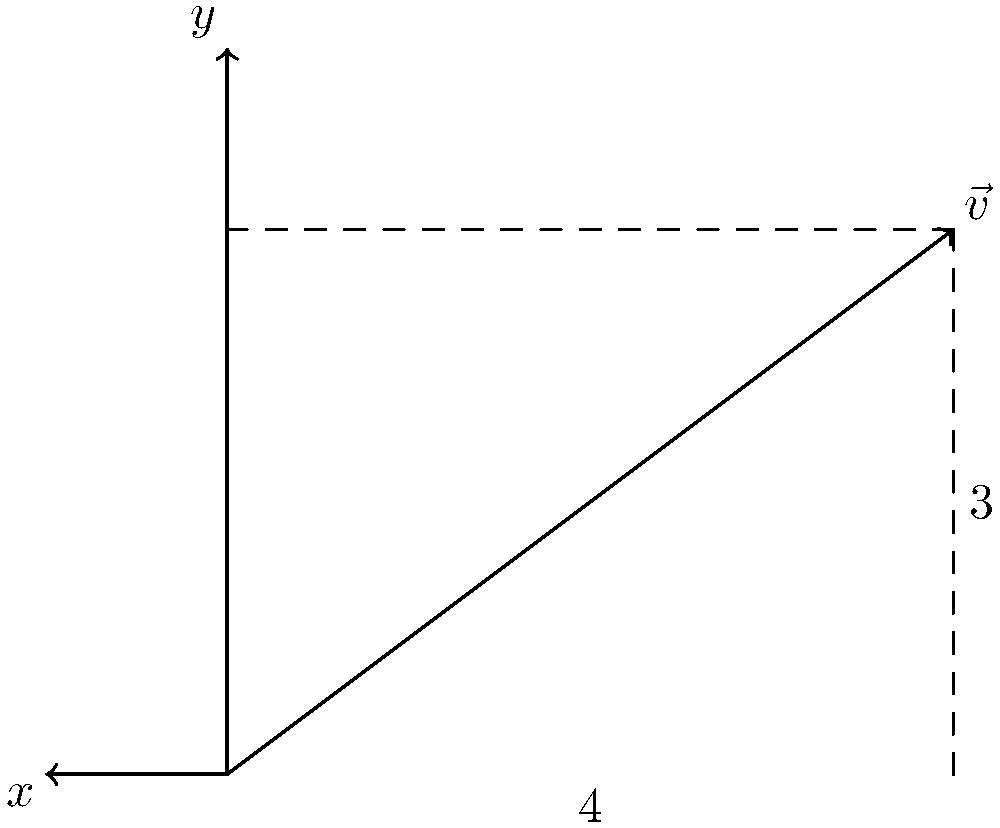Given the vector $\vec{v}$ shown in the figure, decompose it into its $x$ and $y$ components. Express your answer as $\vec{v} = a\hat{i} + b\hat{j}$, where $a$ and $b$ are scalar values, and $\hat{i}$ and $\hat{j}$ are unit vectors in the $x$ and $y$ directions, respectively. To decompose the vector $\vec{v}$ into its $x$ and $y$ components, we need to determine the scalar values $a$ and $b$.

Step 1: Identify the $x$ component
The $x$ component is the horizontal distance from the origin to the tip of the vector. From the figure, we can see that this distance is 4 units.

Step 2: Identify the $y$ component
The $y$ component is the vertical distance from the origin to the tip of the vector. From the figure, we can see that this distance is 3 units.

Step 3: Express the vector in component form
Now that we have identified both components, we can express the vector as:

$$\vec{v} = 4\hat{i} + 3\hat{j}$$

Where:
- $4\hat{i}$ represents the $x$ component (4 units in the positive $x$ direction)
- $3\hat{j}$ represents the $y$ component (3 units in the positive $y$ direction)

This decomposition allows us to represent the vector $\vec{v}$ as the sum of its horizontal and vertical components.
Answer: $\vec{v} = 4\hat{i} + 3\hat{j}$ 